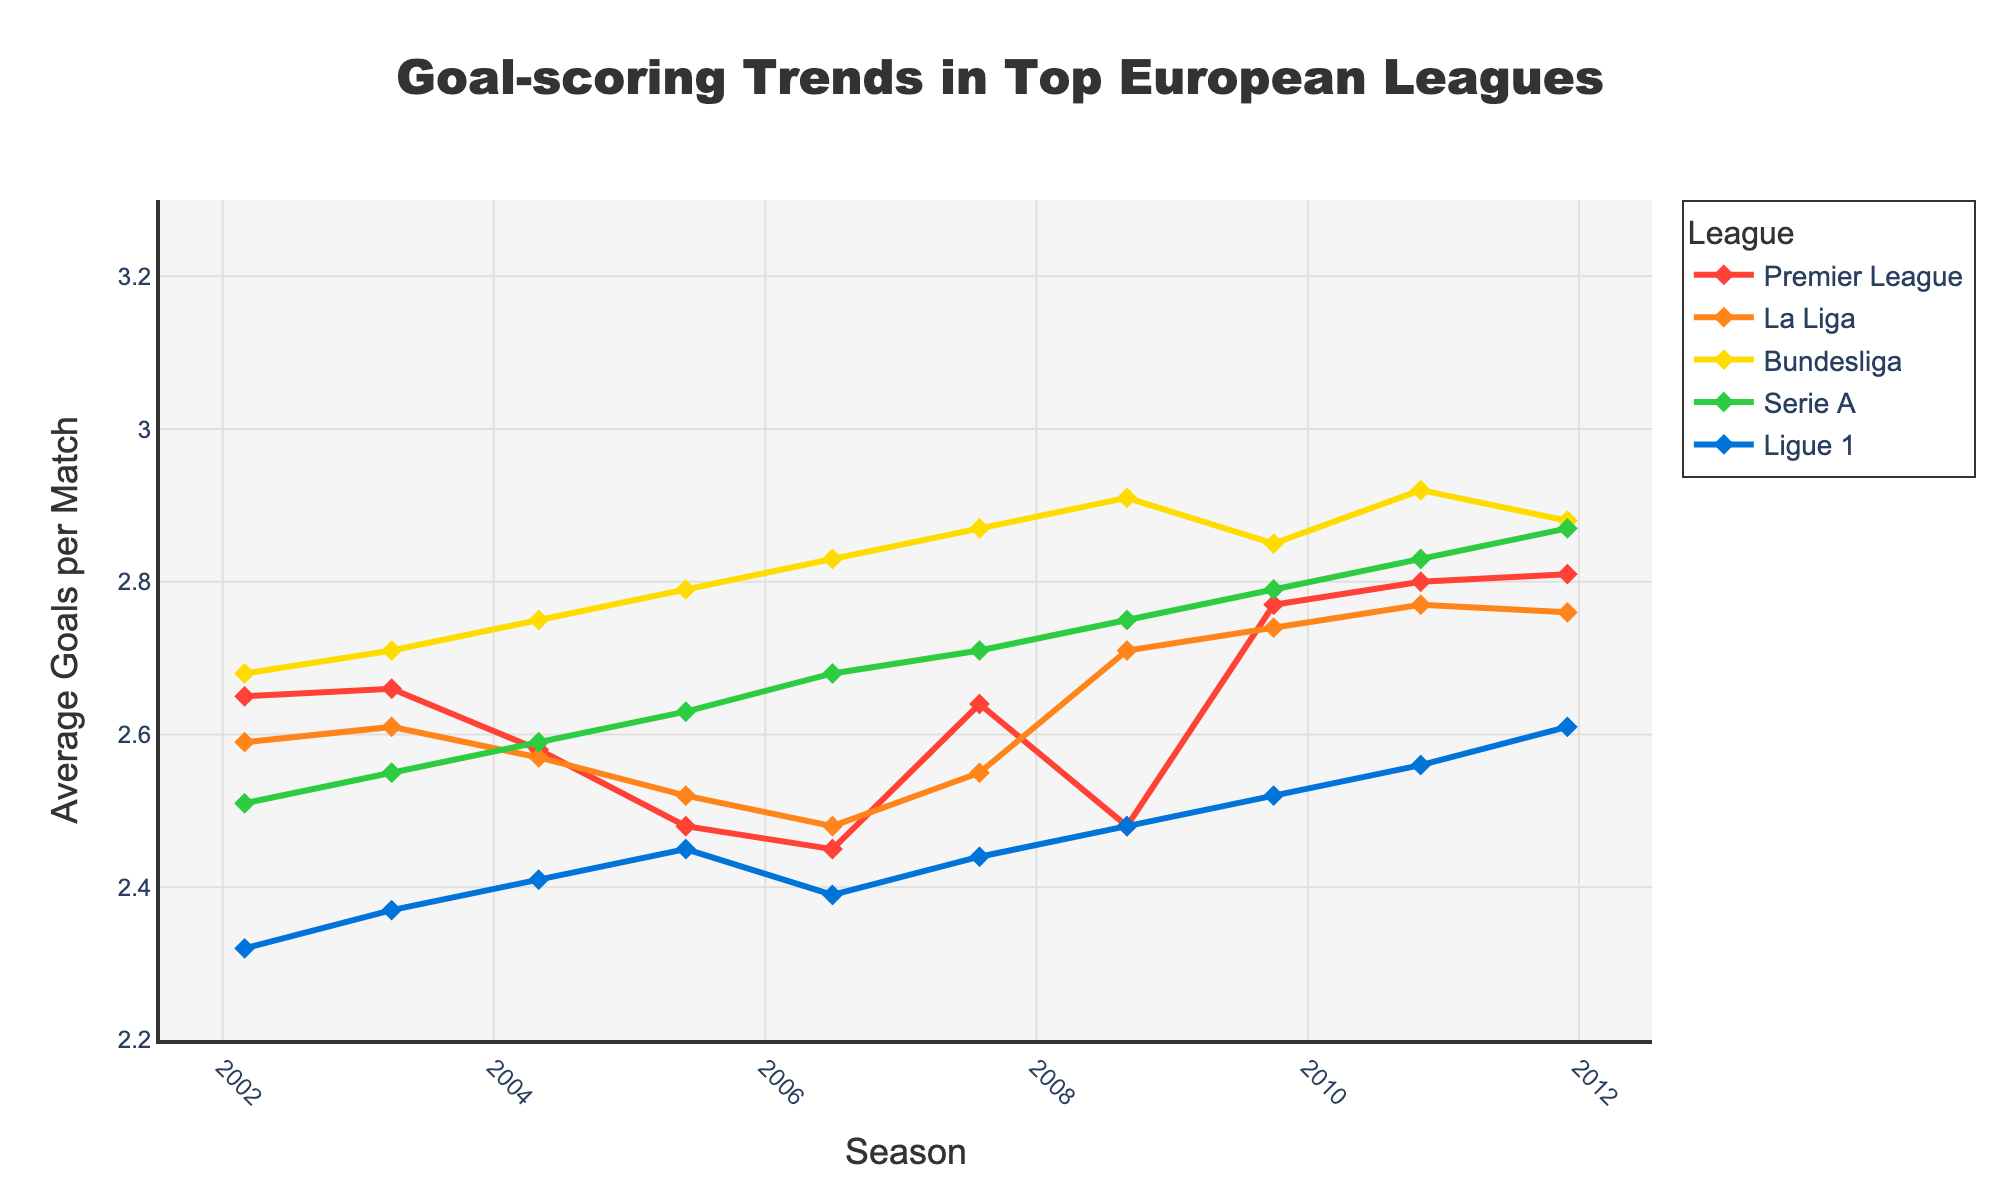what's the trend in the average goals per match in the Bundesliga from the 2002-03 season to the 2021-22 season? To find the trend, observe the line representing the Bundesliga across the seasons. Starting at 2.68 goals per match in 2002-03, it mostly increases, reaching around 3.12 goals per match by 2021-22, indicating an upward trend.
Answer: Upward trend which league had the highest average goals per match in the 2021-22 season? Look at the 2021-22 data points on the chart. Bundesliga has the highest value, around 3.12 goals per match.
Answer: Bundesliga how did the average goals per match in Serie A change from 2014-15 to 2020-21? For Serie A, note the values from 2014-15 (2.88) to 2020-21 (3.06). The number increases, indicating more goals per match in 2020-21 compared to 2014-15.
Answer: Increased compare the goal-scoring trends in La Liga and Ligue 1 from 2002-03 to 2021-22. Analyze both lines: La Liga starts higher, fluctuates, and ends slightly below its peak. Ligue 1 starts lower, also fluctuates, but ends up closer to its starting value. Comparing both, La Liga typically has higher averages and more variation than Ligue 1.
Answer: La Liga higher, more variation which league showed the most significant increase in average goals per match over the 20 seasons? Look for the line with the most considerable rise from 2002-03 to 2021-22. Bundesliga increased from 2.68 to about 3.12, which is roughly a 0.44 gain, the most significant among the leagues.
Answer: Bundesliga which season had the lowest average goals per match in the Premier League? Identify the lowest point on the Premier League line, which is around the 2006-07 season with approximately 2.45 goals per match.
Answer: 2006-07 what was the difference in average goals per match between the Premier League and La Liga in the 2010-11 season? Find the 2010-11 values for both leagues: Premier League (2.80) and La Liga (2.77). The difference is 2.80 - 2.77 = 0.03 goals per match.
Answer: 0.03 compare the range of average goals per match in Ligue 1 and the Bundesliga over the 20 seasons. Range = max - min. For Ligue 1: max ~2.81 (2021-22) and min ~2.32 (2002-03); range is 2.81 - 2.32 = 0.49. For Bundesliga: max ~3.21 (2019-20) and min ~2.68 (2002-03); range is 3.21 - 2.68 = 0.53. The Bundesliga has a slightly larger range.
Answer: Bundesliga, larger range 